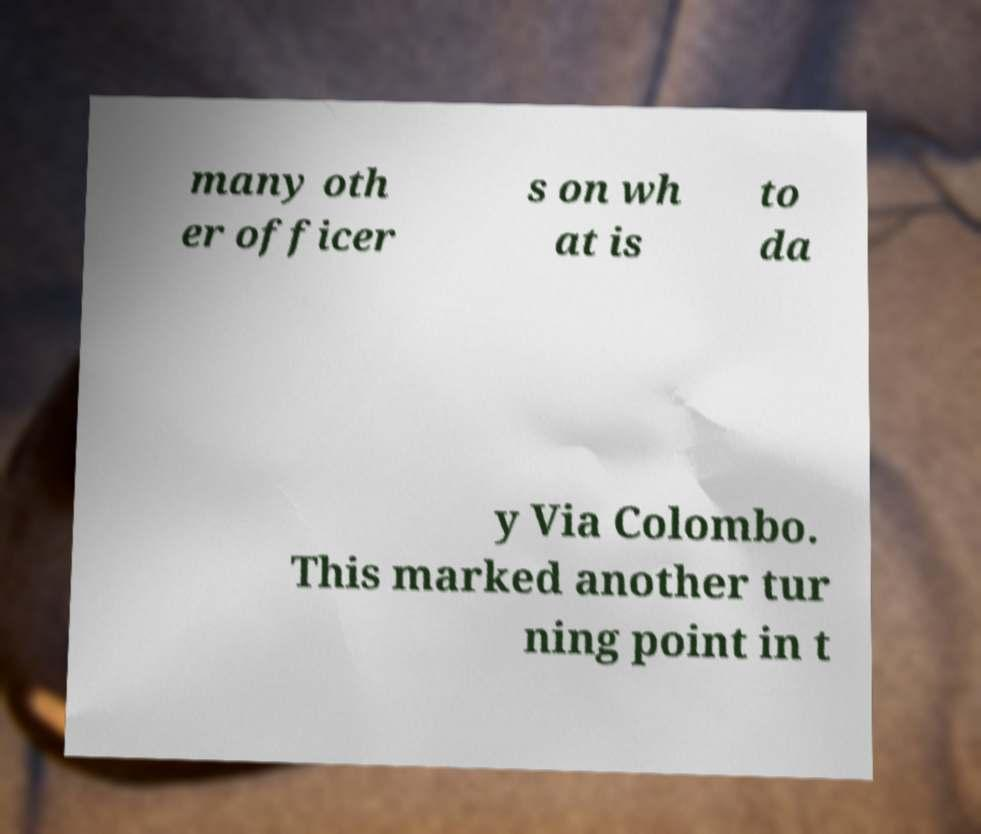Could you extract and type out the text from this image? many oth er officer s on wh at is to da y Via Colombo. This marked another tur ning point in t 